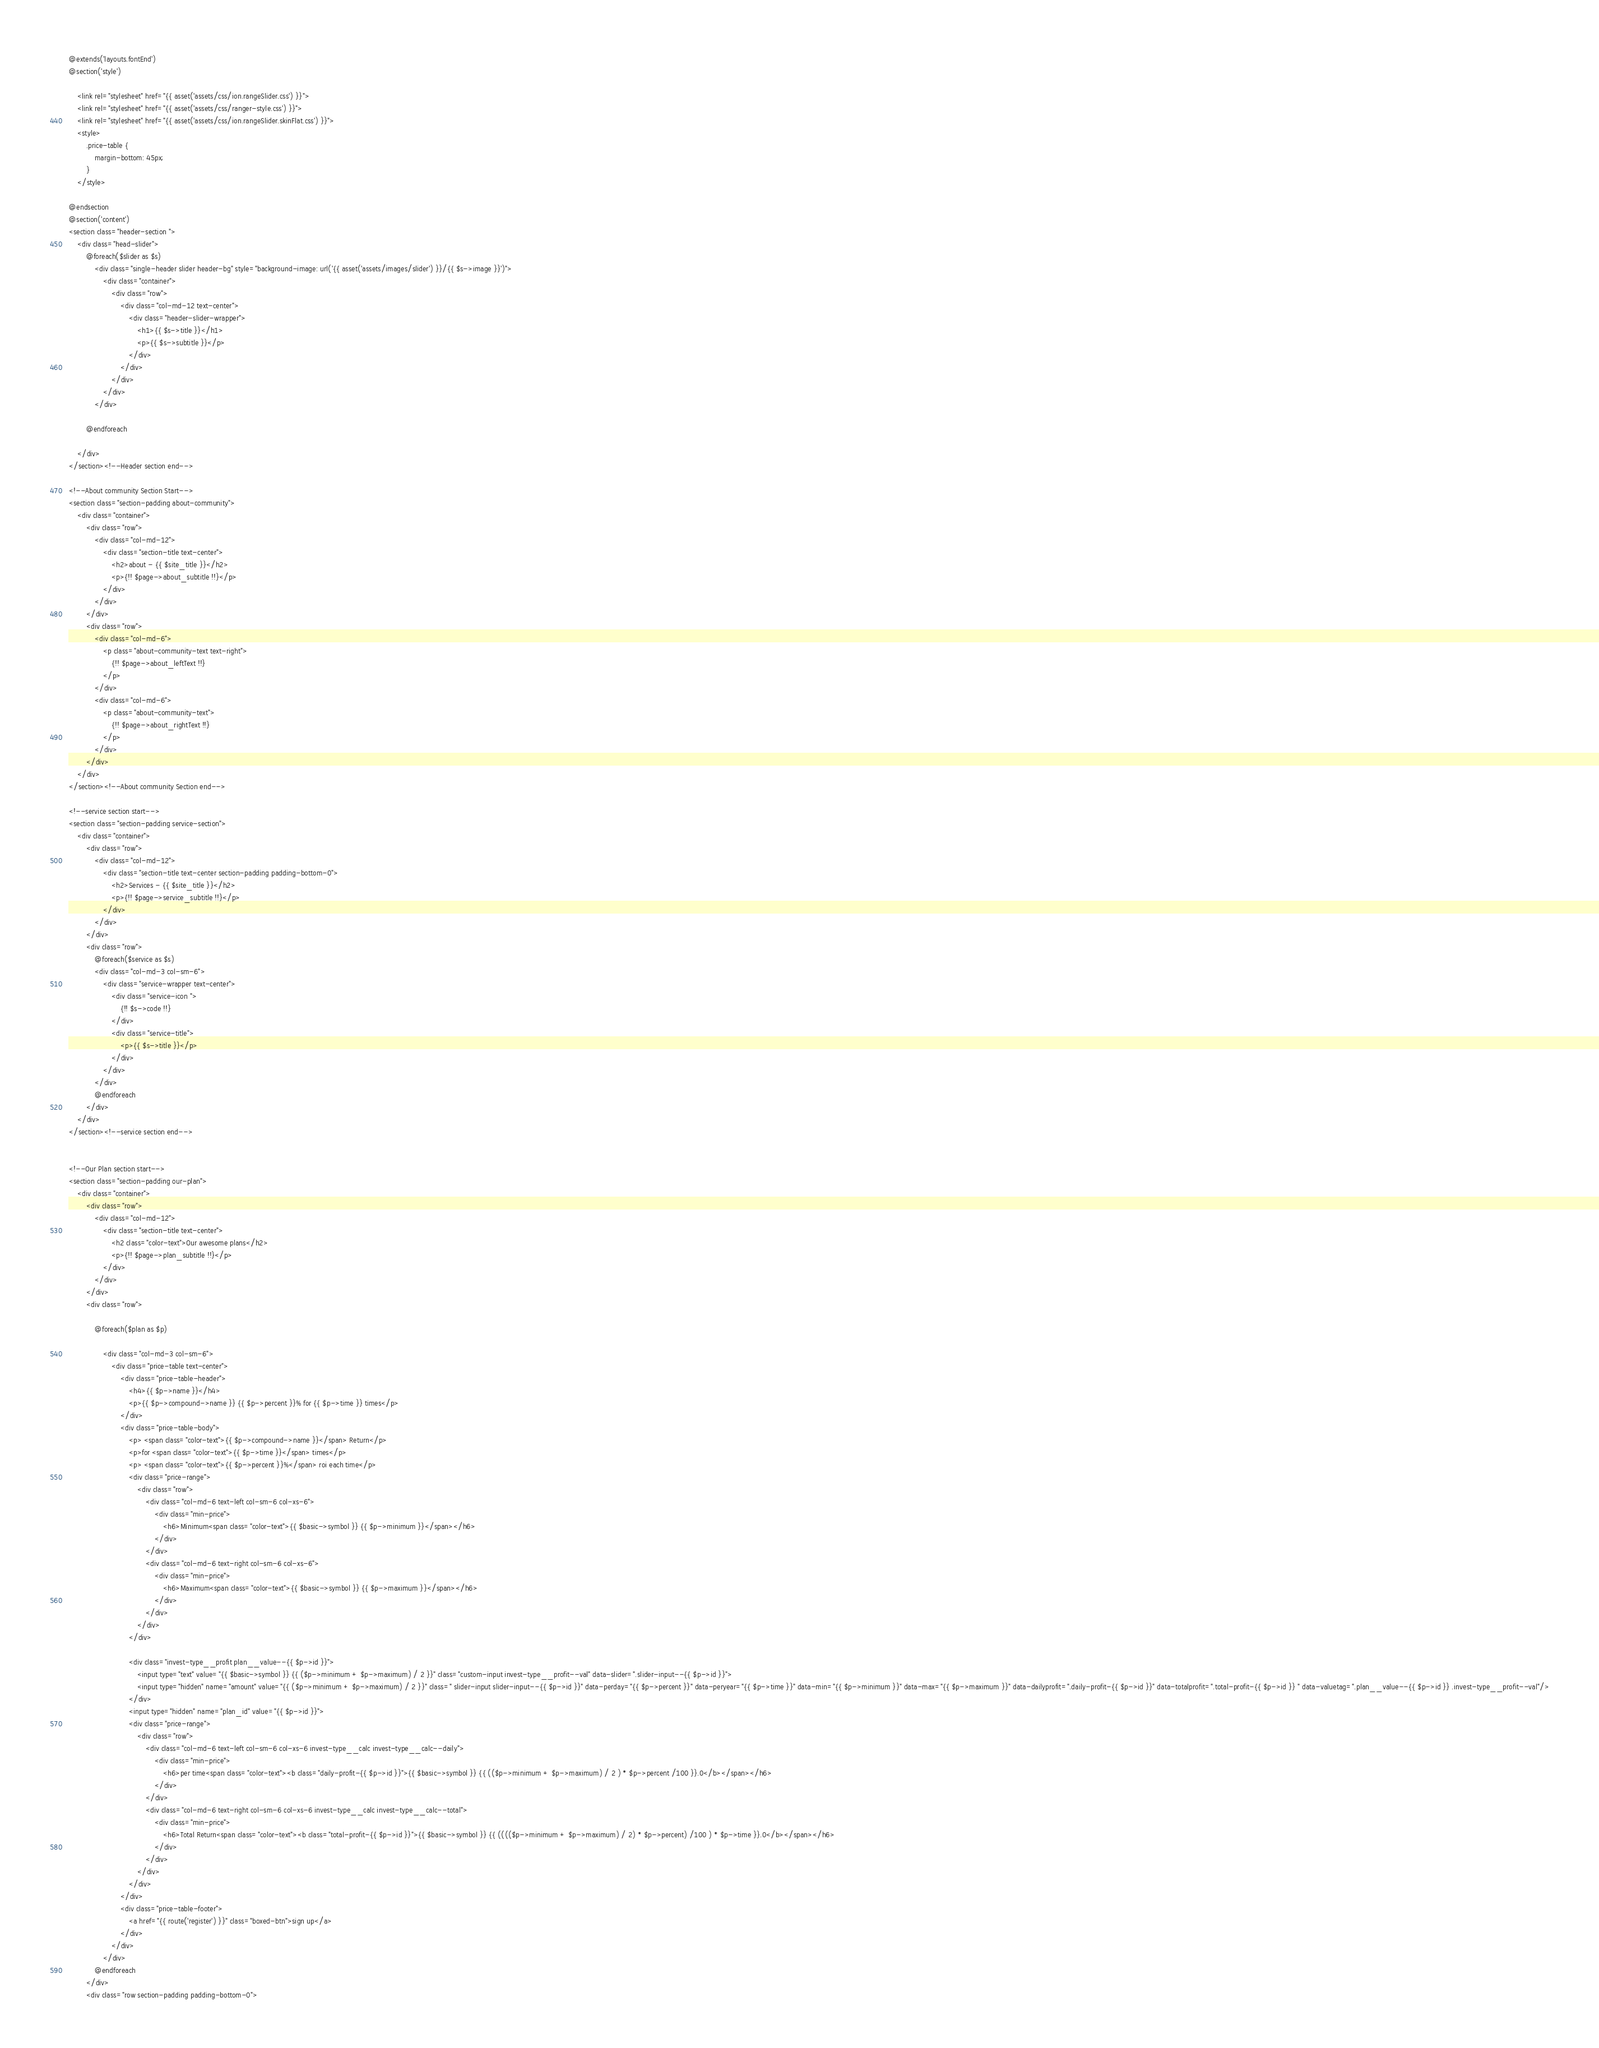<code> <loc_0><loc_0><loc_500><loc_500><_PHP_>@extends('layouts.fontEnd')
@section('style')

    <link rel="stylesheet" href="{{ asset('assets/css/ion.rangeSlider.css') }}">
    <link rel="stylesheet" href="{{ asset('assets/css/ranger-style.css') }}">
    <link rel="stylesheet" href="{{ asset('assets/css/ion.rangeSlider.skinFlat.css') }}">
    <style>
        .price-table {
            margin-bottom: 45px;
        }
    </style>

@endsection
@section('content')
<section class="header-section ">
    <div class="head-slider">
        @foreach($slider as $s)
            <div class="single-header slider header-bg" style="background-image: url('{{ asset('assets/images/slider') }}/{{ $s->image }}')">
                <div class="container">
                    <div class="row">
                        <div class="col-md-12 text-center">
                            <div class="header-slider-wrapper">
                                <h1>{{ $s->title }}</h1>
                                <p>{{ $s->subtitle }}</p>
                            </div>
                        </div>
                    </div>
                </div>
            </div>

        @endforeach

    </div>
</section><!--Header section end-->

<!--About community Section Start-->
<section class="section-padding about-community">
    <div class="container">
        <div class="row">
            <div class="col-md-12">
                <div class="section-title text-center">
                    <h2>about - {{ $site_title }}</h2>
                    <p>{!! $page->about_subtitle !!}</p>
                </div>
            </div>
        </div>
        <div class="row">
            <div class="col-md-6">
                <p class="about-community-text text-right">
                    {!! $page->about_leftText !!}
                </p>
            </div>
            <div class="col-md-6">
                <p class="about-community-text">
                    {!! $page->about_rightText !!}
                </p>
            </div>
        </div>
    </div>
</section><!--About community Section end-->

<!--service section start-->
<section class="section-padding service-section">
    <div class="container">
        <div class="row">
            <div class="col-md-12">
                <div class="section-title text-center section-padding padding-bottom-0">
                    <h2>Services - {{ $site_title }}</h2>
                    <p>{!! $page->service_subtitle !!}</p>
                </div>
            </div>
        </div>
        <div class="row">
            @foreach($service as $s)
            <div class="col-md-3 col-sm-6">
                <div class="service-wrapper text-center">
                    <div class="service-icon ">
                        {!! $s->code !!}
                    </div>
                    <div class="service-title">
                        <p>{{ $s->title }}</p>
                    </div>
                </div>
            </div>
            @endforeach
        </div>
    </div>
</section><!--service section end-->


<!--Our Plan section start-->
<section class="section-padding our-plan">
    <div class="container">
        <div class="row">
            <div class="col-md-12">
                <div class="section-title text-center">
                    <h2 class="color-text">Our awesome plans</h2>
                    <p>{!! $page->plan_subtitle !!}</p>
                </div>
            </div>
        </div>
        <div class="row">

            @foreach($plan as $p)

                <div class="col-md-3 col-sm-6">
                    <div class="price-table text-center">
                        <div class="price-table-header">
                            <h4>{{ $p->name }}</h4>
                            <p>{{ $p->compound->name }} {{ $p->percent }}% for {{ $p->time }} times</p>
                        </div>
                        <div class="price-table-body">
                            <p> <span class="color-text">{{ $p->compound->name }}</span> Return</p>
                            <p>for <span class="color-text">{{ $p->time }}</span> times</p>
                            <p> <span class="color-text">{{ $p->percent }}%</span> roi each time</p>
                            <div class="price-range">
                                <div class="row">
                                    <div class="col-md-6 text-left col-sm-6 col-xs-6">
                                        <div class="min-price">
                                            <h6>Minimum<span class="color-text">{{ $basic->symbol }} {{ $p->minimum }}</span></h6>
                                        </div>
                                    </div>
                                    <div class="col-md-6 text-right col-sm-6 col-xs-6">
                                        <div class="min-price">
                                            <h6>Maximum<span class="color-text">{{ $basic->symbol }} {{ $p->maximum }}</span></h6>
                                        </div>
                                    </div>
                                </div>
                            </div>

                            <div class="invest-type__profit plan__value--{{ $p->id }}">
                                <input type="text" value="{{ $basic->symbol }} {{ ($p->minimum + $p->maximum) / 2 }}" class="custom-input invest-type__profit--val" data-slider=".slider-input--{{ $p->id }}">
                                <input type="hidden" name="amount" value="{{ ($p->minimum + $p->maximum) / 2 }}" class=" slider-input slider-input--{{ $p->id }}" data-perday="{{ $p->percent }}" data-peryear="{{ $p->time }}" data-min="{{ $p->minimum }}" data-max="{{ $p->maximum }}" data-dailyprofit=".daily-profit-{{ $p->id }}" data-totalprofit=".total-profit-{{ $p->id }} " data-valuetag=".plan__value--{{ $p->id }} .invest-type__profit--val"/>
                            </div>
                            <input type="hidden" name="plan_id" value="{{ $p->id }}">
                            <div class="price-range">
                                <div class="row">
                                    <div class="col-md-6 text-left col-sm-6 col-xs-6 invest-type__calc invest-type__calc--daily">
                                        <div class="min-price">
                                            <h6>per time<span class="color-text"><b class="daily-profit-{{ $p->id }}">{{ $basic->symbol }} {{ (($p->minimum + $p->maximum) / 2 ) * $p->percent /100 }}.0</b></span></h6>
                                        </div>
                                    </div>
                                    <div class="col-md-6 text-right col-sm-6 col-xs-6 invest-type__calc invest-type__calc--total">
                                        <div class="min-price">
                                            <h6>Total Return<span class="color-text"><b class="total-profit-{{ $p->id }}">{{ $basic->symbol }} {{ (((($p->minimum + $p->maximum) / 2) * $p->percent) /100 ) * $p->time }}.0</b></span></h6>
                                        </div>
                                    </div>
                                </div>
                            </div>
                        </div>
                        <div class="price-table-footer">
                            <a href="{{ route('register') }}" class="boxed-btn">sign up</a>
                        </div>
                    </div>
                </div>
            @endforeach
        </div>
        <div class="row section-padding padding-bottom-0"></code> 